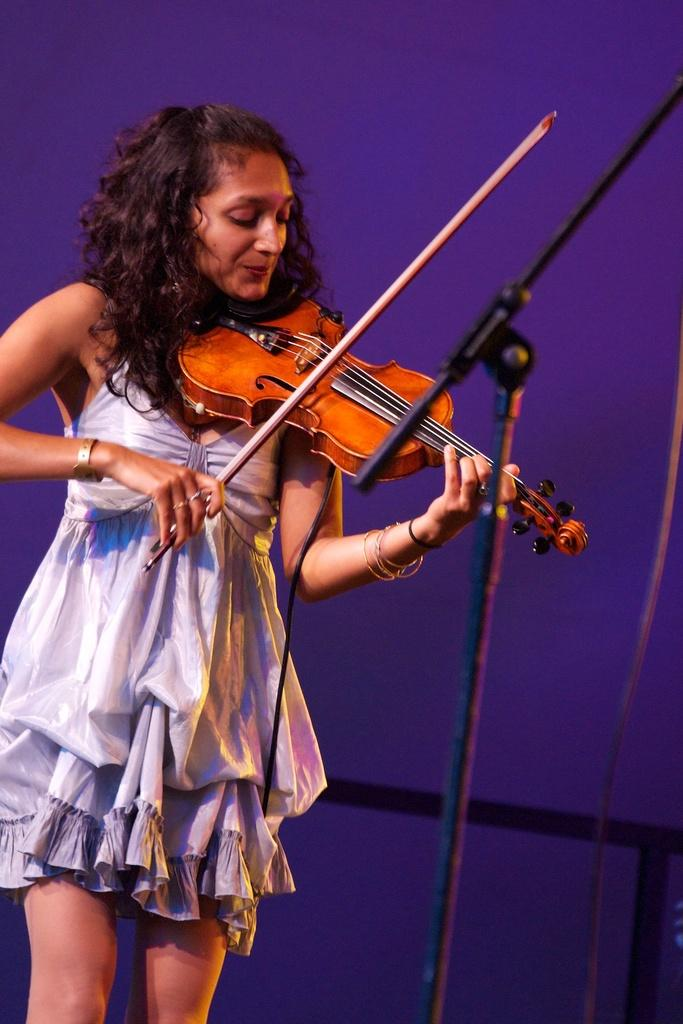Who is the main subject in the image? There is a woman in the image. What is the woman doing in the image? The woman is standing and playing a violin. What is in front of the woman in the image? There is a see-through mic stand in front of the woman. What can be seen in the background of the image? There is a wall visible in the background of the image. What type of tooth is visible in the image? There is no tooth visible in the image. Is the woman performing on a stage in the image? The image does not show a stage, so it cannot be determined if the woman is performing on one. 